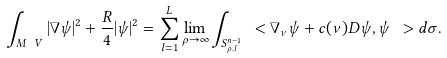<formula> <loc_0><loc_0><loc_500><loc_500>\int _ { M \ V } | \nabla \psi | ^ { 2 } + \frac { R } { 4 } | \psi | ^ { 2 } = \sum _ { l = 1 } ^ { L } \lim _ { \rho \to \infty } \int _ { S ^ { n - 1 } _ { \rho , l } } \ < \nabla _ { \nu } \psi + c ( \nu ) D \psi , \psi \ > d \sigma .</formula> 